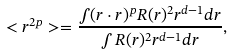Convert formula to latex. <formula><loc_0><loc_0><loc_500><loc_500>< r ^ { 2 p } > = \frac { \int ( { r } \cdot { r } ) ^ { p } R ( r ) ^ { 2 } r ^ { d - 1 } d r } { \int R ( r ) ^ { 2 } r ^ { d - 1 } d r } ,</formula> 